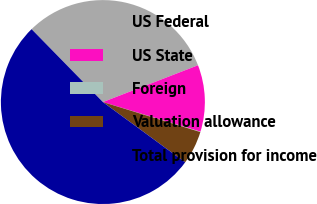Convert chart. <chart><loc_0><loc_0><loc_500><loc_500><pie_chart><fcel>US Federal<fcel>US State<fcel>Foreign<fcel>Valuation allowance<fcel>Total provision for income<nl><fcel>31.45%<fcel>10.57%<fcel>0.06%<fcel>5.31%<fcel>52.61%<nl></chart> 